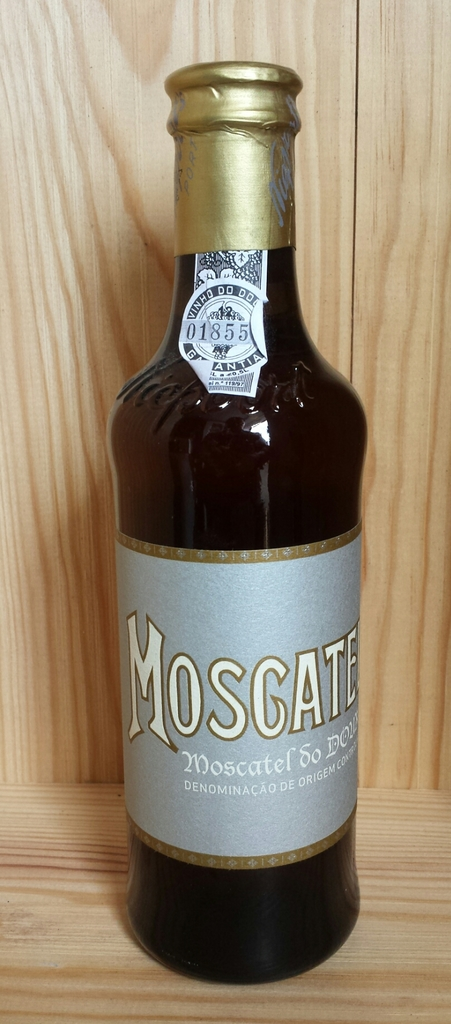Provide a one-sentence caption for the provided image.
Reference OCR token: AYCKS, HO.DD.DO, 01855, MOSCAT, DOL, Moscatel, 60, DENOMINA, DENOMINACAO..RIGE A glass bottle of Moscatel standing inside of a wooden cabinet. 